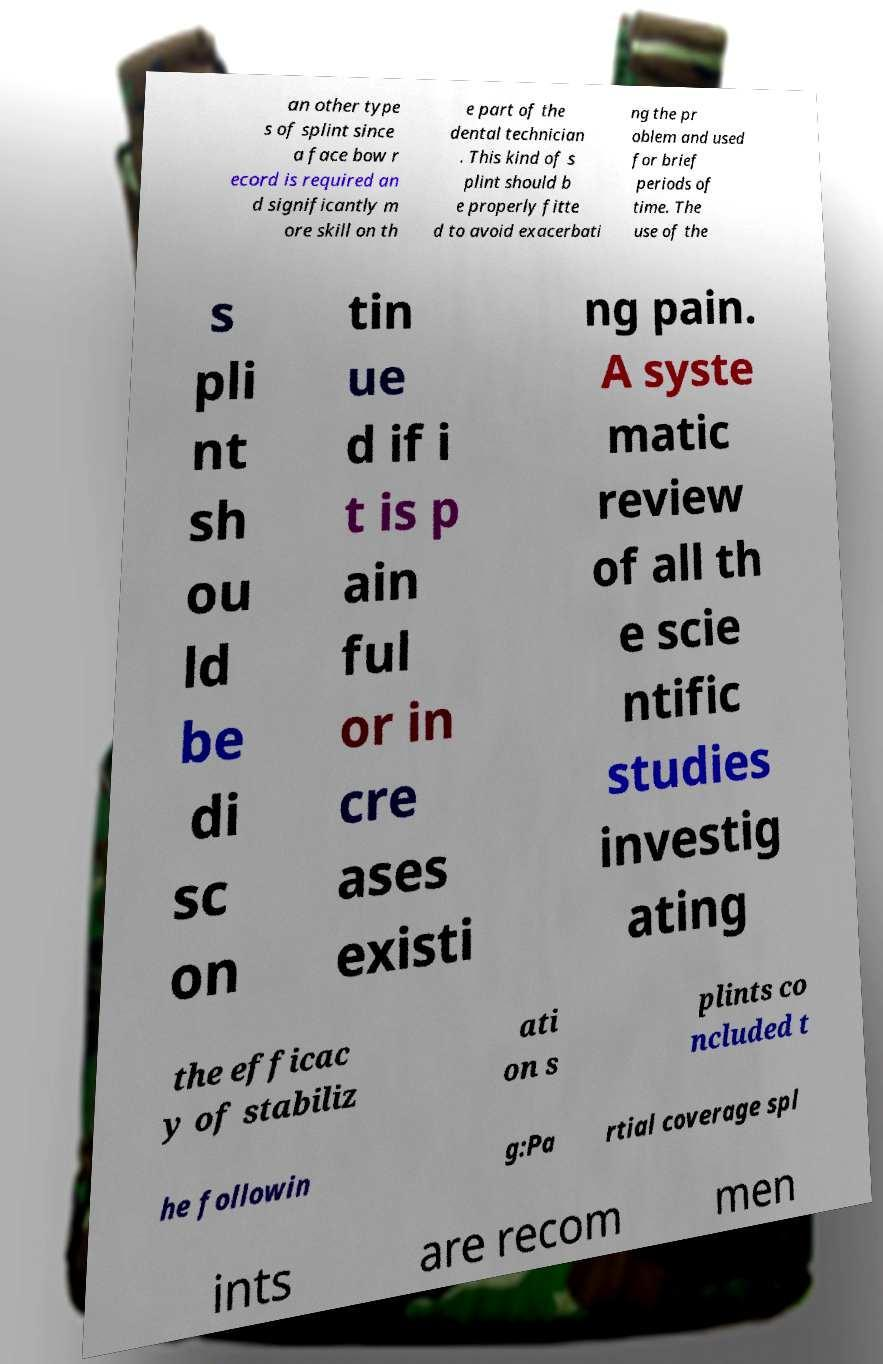For documentation purposes, I need the text within this image transcribed. Could you provide that? an other type s of splint since a face bow r ecord is required an d significantly m ore skill on th e part of the dental technician . This kind of s plint should b e properly fitte d to avoid exacerbati ng the pr oblem and used for brief periods of time. The use of the s pli nt sh ou ld be di sc on tin ue d if i t is p ain ful or in cre ases existi ng pain. A syste matic review of all th e scie ntific studies investig ating the efficac y of stabiliz ati on s plints co ncluded t he followin g:Pa rtial coverage spl ints are recom men 